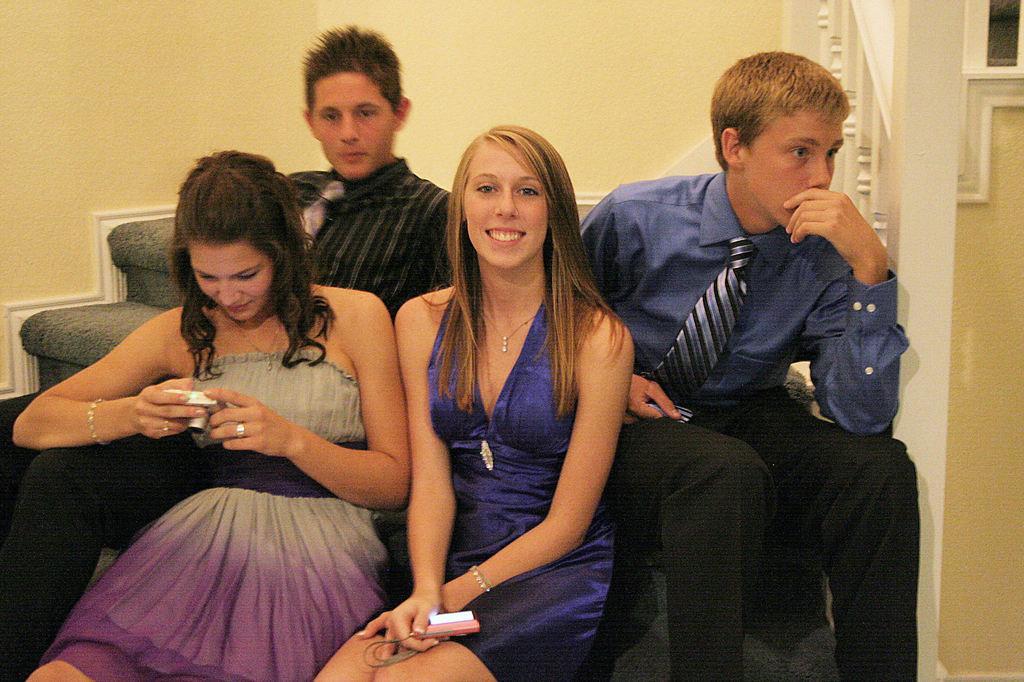Could you give a brief overview of what you see in this image? In the image there is are two women and two men sitting on sofa, behind them there is wall. 